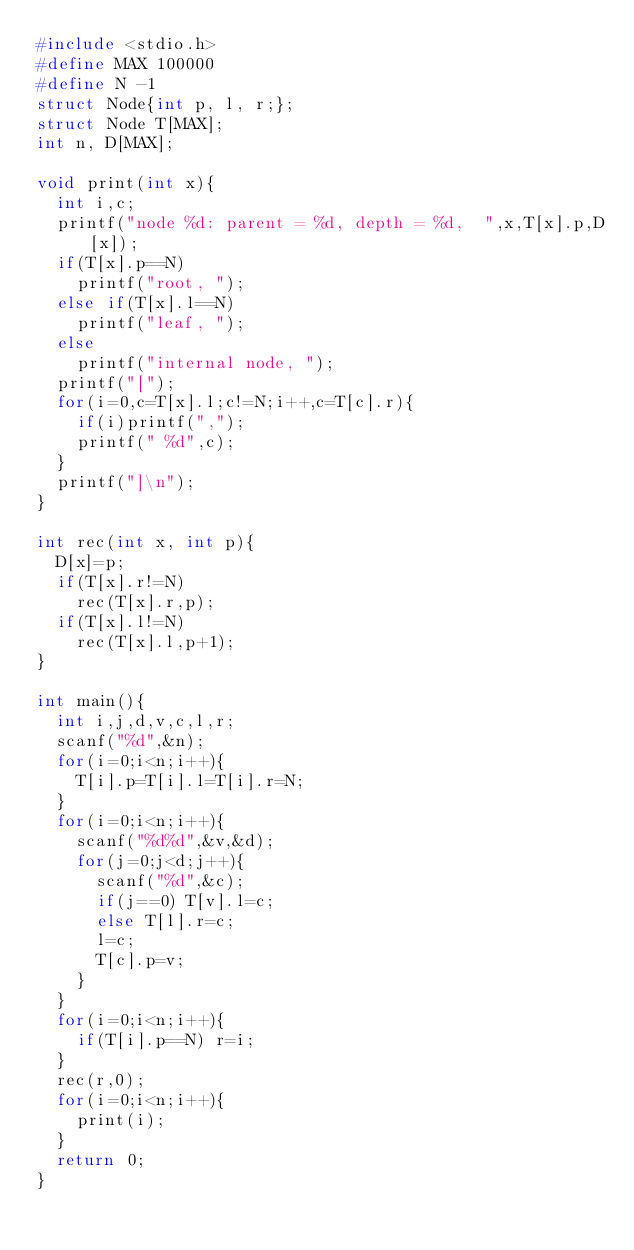Convert code to text. <code><loc_0><loc_0><loc_500><loc_500><_C_>#include <stdio.h>
#define MAX 100000
#define N -1
struct Node{int p, l, r;};
struct Node T[MAX];
int n, D[MAX];
 
void print(int x){
  int i,c;
  printf("node %d: parent = %d, depth = %d,  ",x,T[x].p,D[x]);
  if(T[x].p==N)
    printf("root, ");
  else if(T[x].l==N)
    printf("leaf, ");
  else
    printf("internal node, ");
  printf("[");
  for(i=0,c=T[x].l;c!=N;i++,c=T[c].r){
    if(i)printf(",");
    printf(" %d",c);
  }
  printf("]\n");
}
 
int rec(int x, int p){
  D[x]=p;
  if(T[x].r!=N)
    rec(T[x].r,p);
  if(T[x].l!=N)
    rec(T[x].l,p+1);
}
 
int main(){
  int i,j,d,v,c,l,r;
  scanf("%d",&n);
  for(i=0;i<n;i++){
    T[i].p=T[i].l=T[i].r=N;
  }
  for(i=0;i<n;i++){
    scanf("%d%d",&v,&d);
    for(j=0;j<d;j++){
      scanf("%d",&c);
      if(j==0) T[v].l=c;
      else T[l].r=c;
      l=c;
      T[c].p=v;
    }
  }
  for(i=0;i<n;i++){
    if(T[i].p==N) r=i;
  }
  rec(r,0);
  for(i=0;i<n;i++){
    print(i);
  }
  return 0;
}</code> 